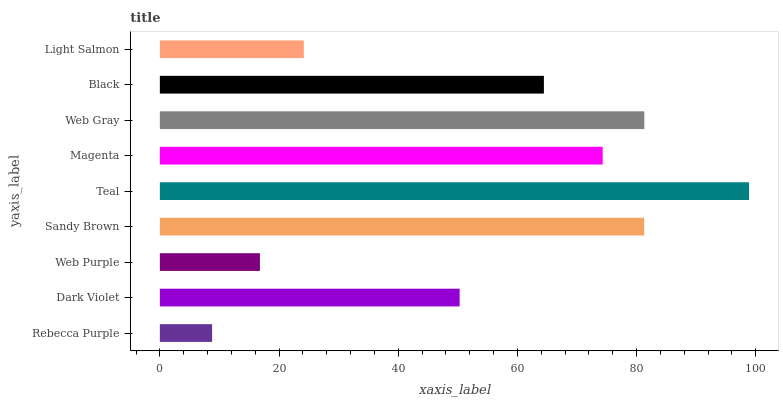Is Rebecca Purple the minimum?
Answer yes or no. Yes. Is Teal the maximum?
Answer yes or no. Yes. Is Dark Violet the minimum?
Answer yes or no. No. Is Dark Violet the maximum?
Answer yes or no. No. Is Dark Violet greater than Rebecca Purple?
Answer yes or no. Yes. Is Rebecca Purple less than Dark Violet?
Answer yes or no. Yes. Is Rebecca Purple greater than Dark Violet?
Answer yes or no. No. Is Dark Violet less than Rebecca Purple?
Answer yes or no. No. Is Black the high median?
Answer yes or no. Yes. Is Black the low median?
Answer yes or no. Yes. Is Teal the high median?
Answer yes or no. No. Is Dark Violet the low median?
Answer yes or no. No. 